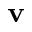Convert formula to latex. <formula><loc_0><loc_0><loc_500><loc_500>v</formula> 